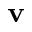Convert formula to latex. <formula><loc_0><loc_0><loc_500><loc_500>v</formula> 